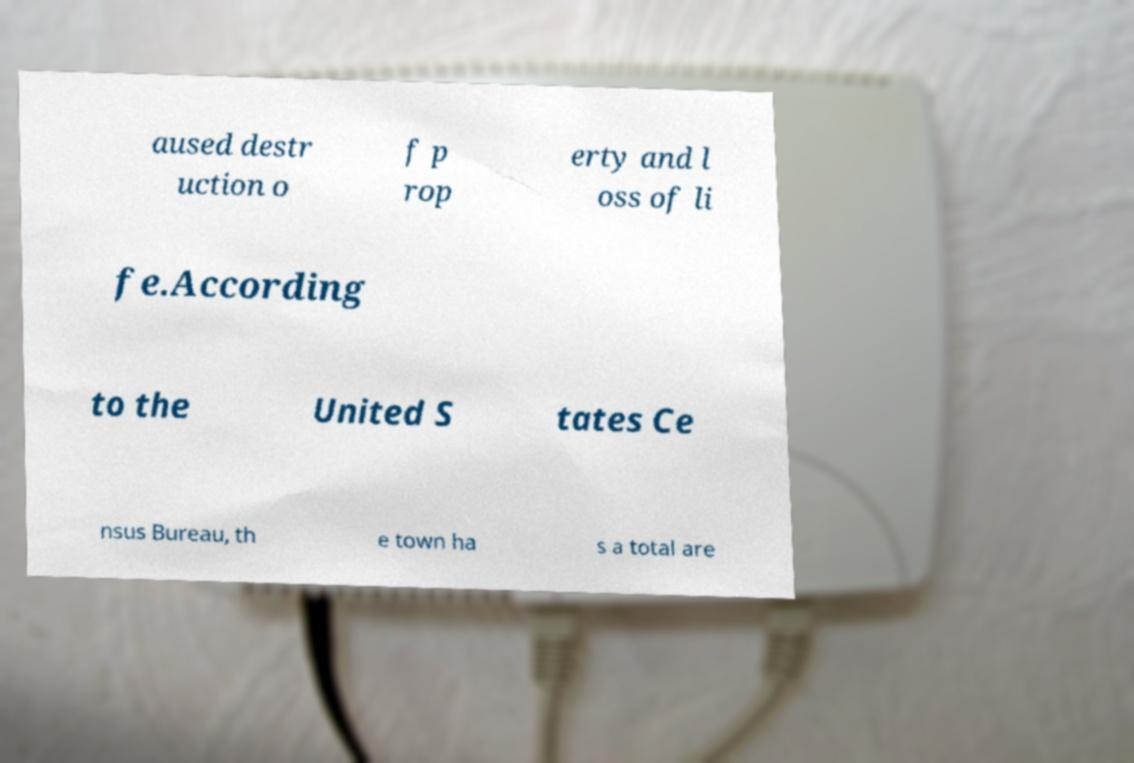Could you extract and type out the text from this image? aused destr uction o f p rop erty and l oss of li fe.According to the United S tates Ce nsus Bureau, th e town ha s a total are 